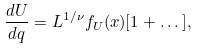Convert formula to latex. <formula><loc_0><loc_0><loc_500><loc_500>\frac { d U } { d q } = L ^ { 1 / \nu } f _ { U } ( x ) [ 1 + \dots ] ,</formula> 